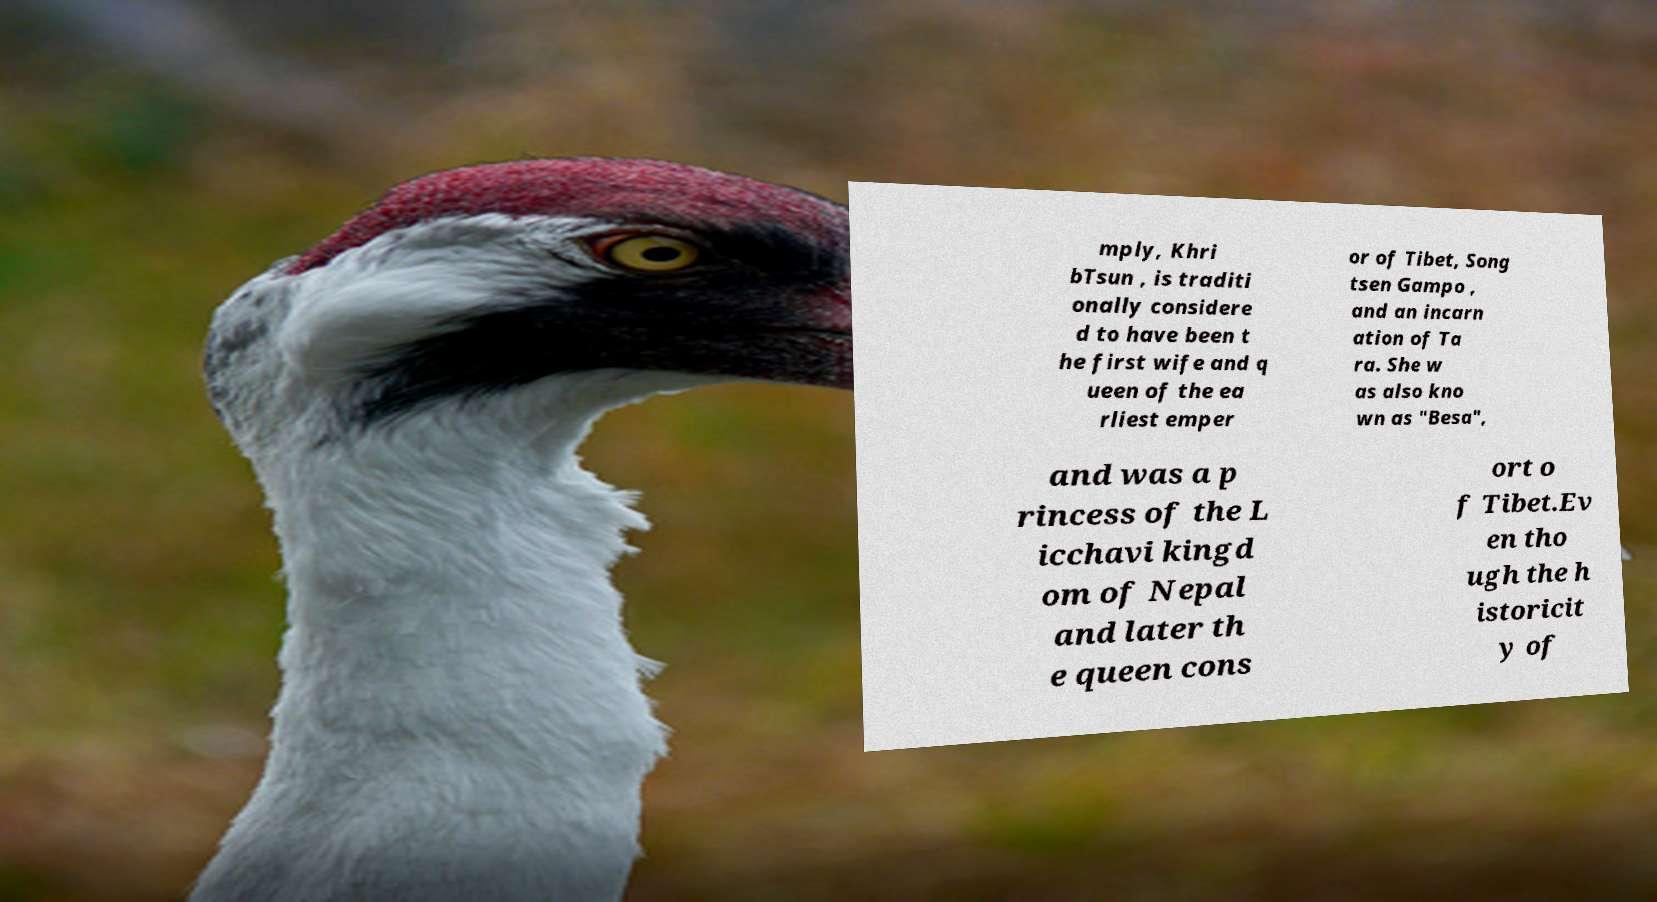Please identify and transcribe the text found in this image. mply, Khri bTsun , is traditi onally considere d to have been t he first wife and q ueen of the ea rliest emper or of Tibet, Song tsen Gampo , and an incarn ation of Ta ra. She w as also kno wn as "Besa", and was a p rincess of the L icchavi kingd om of Nepal and later th e queen cons ort o f Tibet.Ev en tho ugh the h istoricit y of 